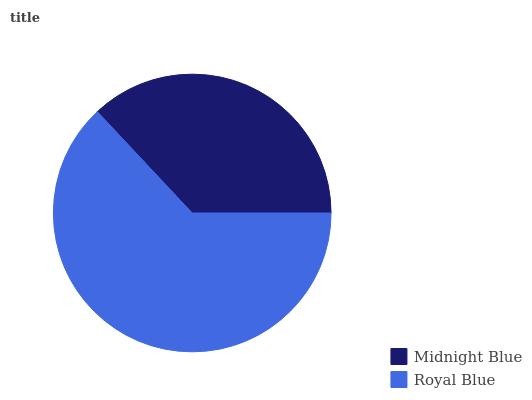Is Midnight Blue the minimum?
Answer yes or no. Yes. Is Royal Blue the maximum?
Answer yes or no. Yes. Is Royal Blue the minimum?
Answer yes or no. No. Is Royal Blue greater than Midnight Blue?
Answer yes or no. Yes. Is Midnight Blue less than Royal Blue?
Answer yes or no. Yes. Is Midnight Blue greater than Royal Blue?
Answer yes or no. No. Is Royal Blue less than Midnight Blue?
Answer yes or no. No. Is Royal Blue the high median?
Answer yes or no. Yes. Is Midnight Blue the low median?
Answer yes or no. Yes. Is Midnight Blue the high median?
Answer yes or no. No. Is Royal Blue the low median?
Answer yes or no. No. 